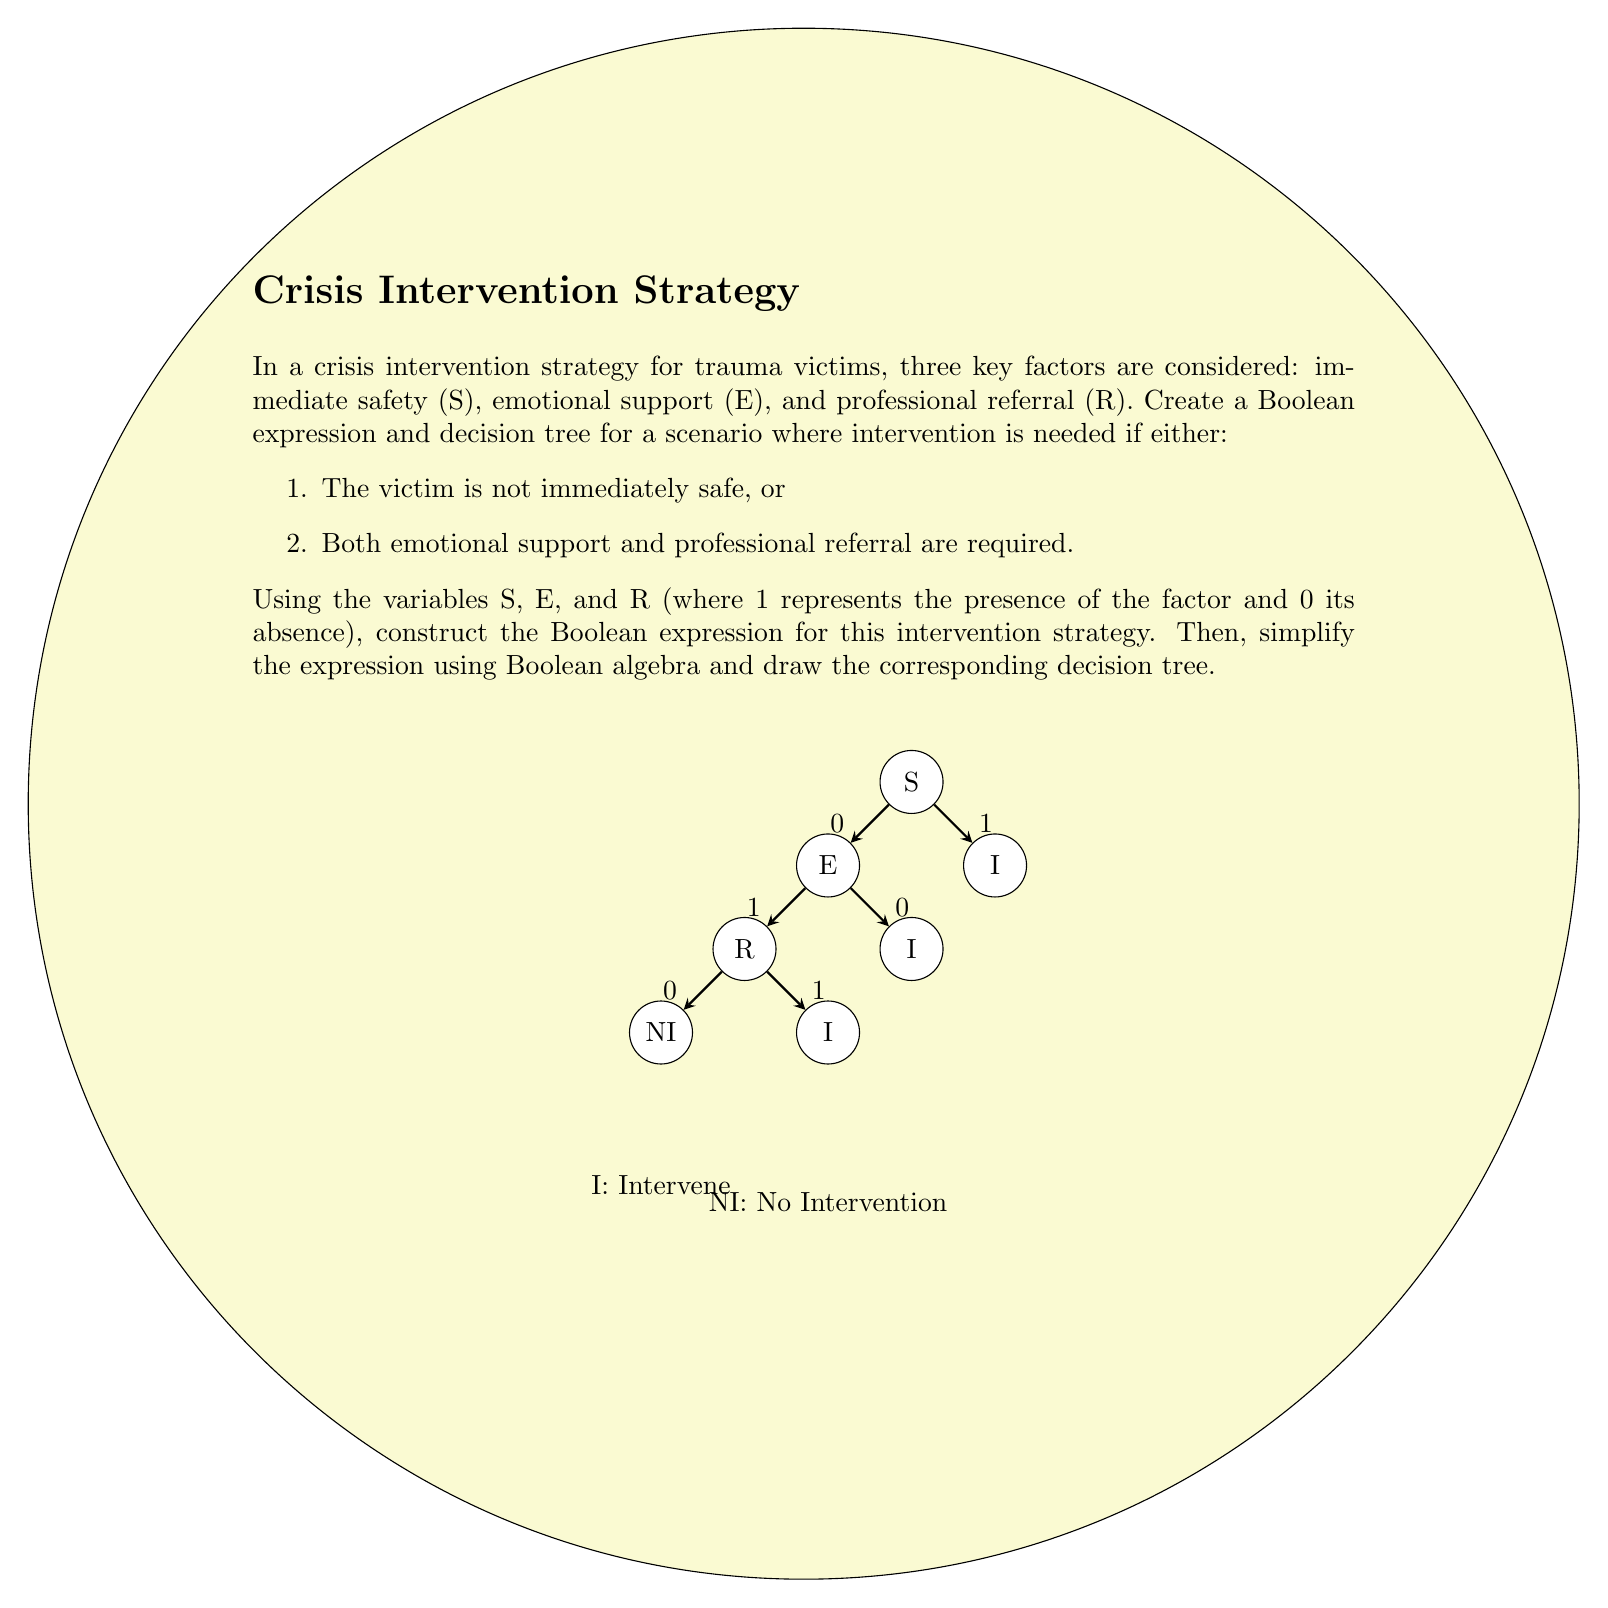Show me your answer to this math problem. Let's approach this step-by-step:

1) First, we need to translate the given conditions into a Boolean expression:
   - Intervention is needed if not immediately safe: $\overline{S}$
   - OR if both emotional support and professional referral are required: $E \cdot R$

2) Combining these conditions, we get the initial Boolean expression:
   $$I = \overline{S} + (E \cdot R)$$
   where $I$ represents the decision to intervene.

3) This expression is already in its simplified form, as it uses the fundamental Boolean operations (NOT, AND, OR) and cannot be reduced further.

4) To create the decision tree, we start with the variable S at the root:
   - If S = 1 (safe), we move to the right branch.
   - If S = 0 (not safe), we move to the left branch and immediately decide to intervene.

5) On the right branch (S = 1), we next consider E:
   - If E = 0, no intervention is needed.
   - If E = 1, we move to consider R.

6) Finally, for the case where S = 1 and E = 1, we consider R:
   - If R = 0, no intervention is needed.
   - If R = 1, intervention is needed.

The decision tree in the question visually represents this logic flow.
Answer: $I = \overline{S} + (E \cdot R)$ 